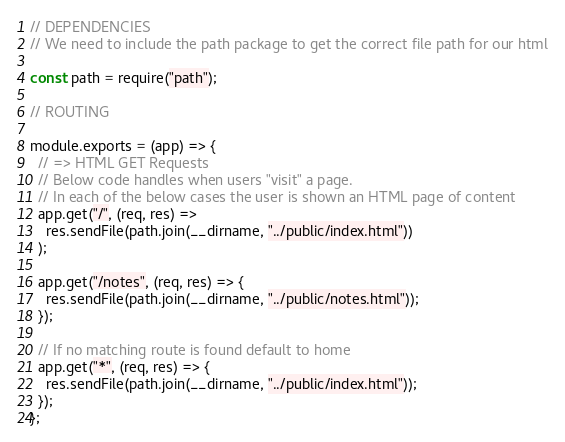<code> <loc_0><loc_0><loc_500><loc_500><_JavaScript_>// DEPENDENCIES
// We need to include the path package to get the correct file path for our html

const path = require("path");

// ROUTING

module.exports = (app) => {
  // => HTML GET Requests
  // Below code handles when users "visit" a page.
  // In each of the below cases the user is shown an HTML page of content
  app.get("/", (req, res) =>
    res.sendFile(path.join(__dirname, "../public/index.html"))
  );

  app.get("/notes", (req, res) => {
    res.sendFile(path.join(__dirname, "../public/notes.html"));
  });

  // If no matching route is found default to home
  app.get("*", (req, res) => {
    res.sendFile(path.join(__dirname, "../public/index.html"));
  });
};
</code> 